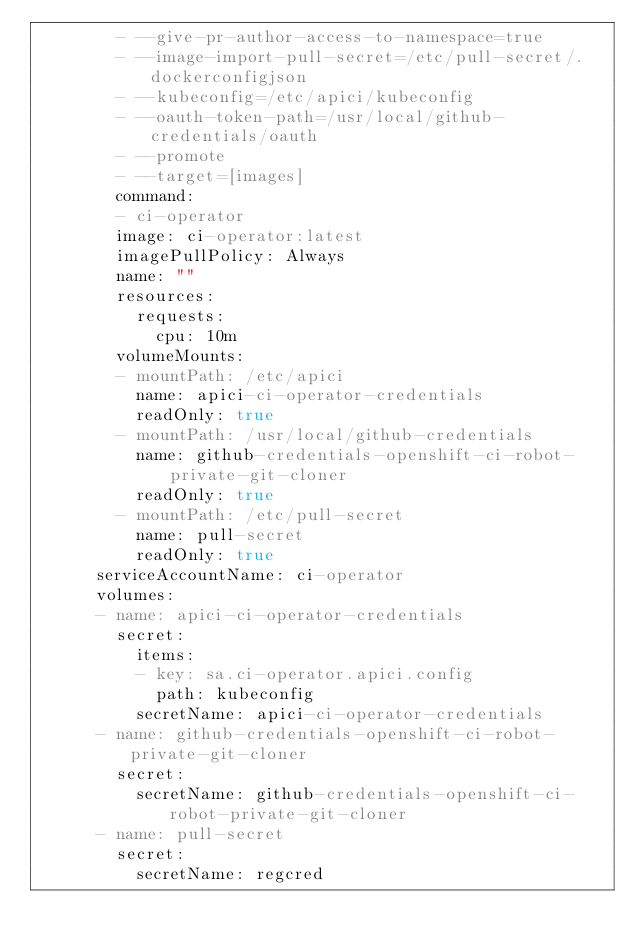Convert code to text. <code><loc_0><loc_0><loc_500><loc_500><_YAML_>        - --give-pr-author-access-to-namespace=true
        - --image-import-pull-secret=/etc/pull-secret/.dockerconfigjson
        - --kubeconfig=/etc/apici/kubeconfig
        - --oauth-token-path=/usr/local/github-credentials/oauth
        - --promote
        - --target=[images]
        command:
        - ci-operator
        image: ci-operator:latest
        imagePullPolicy: Always
        name: ""
        resources:
          requests:
            cpu: 10m
        volumeMounts:
        - mountPath: /etc/apici
          name: apici-ci-operator-credentials
          readOnly: true
        - mountPath: /usr/local/github-credentials
          name: github-credentials-openshift-ci-robot-private-git-cloner
          readOnly: true
        - mountPath: /etc/pull-secret
          name: pull-secret
          readOnly: true
      serviceAccountName: ci-operator
      volumes:
      - name: apici-ci-operator-credentials
        secret:
          items:
          - key: sa.ci-operator.apici.config
            path: kubeconfig
          secretName: apici-ci-operator-credentials
      - name: github-credentials-openshift-ci-robot-private-git-cloner
        secret:
          secretName: github-credentials-openshift-ci-robot-private-git-cloner
      - name: pull-secret
        secret:
          secretName: regcred
</code> 